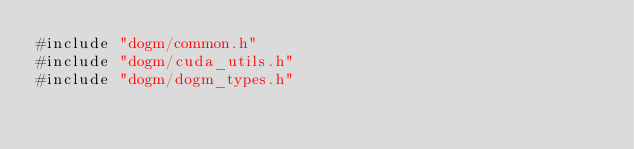<code> <loc_0><loc_0><loc_500><loc_500><_Cuda_>#include "dogm/common.h"
#include "dogm/cuda_utils.h"
#include "dogm/dogm_types.h"</code> 